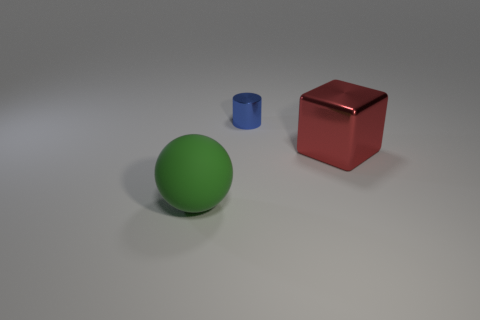Add 2 rubber spheres. How many objects exist? 5 Subtract all cylinders. How many objects are left? 2 Subtract all brown spheres. How many gray blocks are left? 0 Subtract all blue things. Subtract all large green spheres. How many objects are left? 1 Add 1 big green balls. How many big green balls are left? 2 Add 2 big red metal objects. How many big red metal objects exist? 3 Subtract 0 brown cubes. How many objects are left? 3 Subtract 1 cylinders. How many cylinders are left? 0 